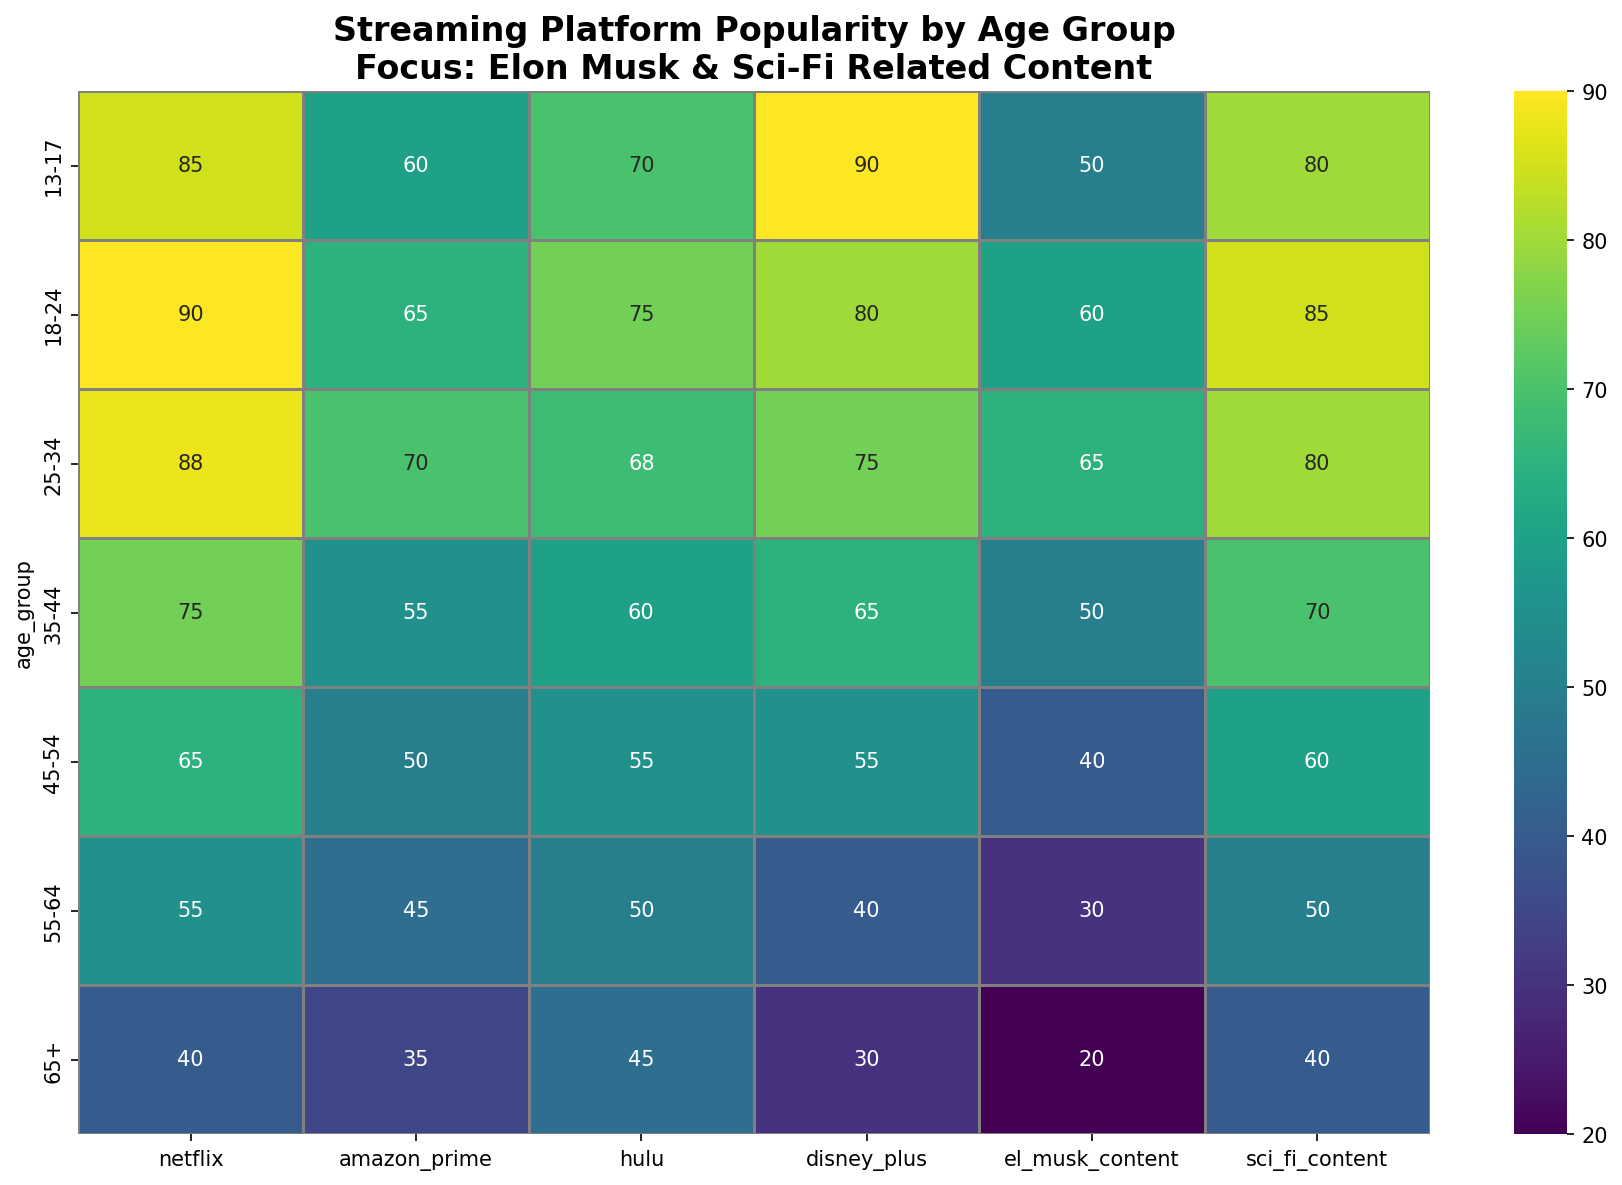What age group has the highest interest in content related to Elon Musk? By looking at the heatmap, we see that the el_musk_content column has the highest value in the 25-34 age group with 65.
Answer: 25-34 Which streaming platform is most popular among the 45-54 age group? The heatmap shows the highest value in the 45-54 age group is for Netflix at 65.
Answer: Netflix What is the difference in popularity of sci-fi content between the 13-17 and 55-64 age groups? The popularity of sci-fi content for ages 13-17 is 80, and for ages 55-64 it is 50. The difference between them is 80 - 50 = 30.
Answer: 30 How does the popularity of Hulu compare between the 18-24 and 35-44 age groups? In the heatmap, the value for Hulu in the 18-24 age group is 75, while that for the 35-44 age group is 60. Thus, Hulu is more popular among the 18-24 age group by 15.
Answer: Hulu is 15 points more popular among the 18-24 age group What is the average popularity of Disney+ across all age groups? To find the average, sum up the Disney+ values for all age groups: 90 + 80 + 75 + 65 + 55 + 40 + 30 = 435. There are 7 age groups, so the average is 435 / 7 ≈ 62.14.
Answer: 62.14 Which age group shows the least interest in content related to Elon Musk? According to the heatmap, the lowest value in the el_musk_content column is in the 65+ age group, with a value of 20.
Answer: 65+ What is the total popularity of Netflix and Amazon Prime in the 25-34 age group? For the 25-34 age group, the popularity of Netflix is 88 and Amazon Prime is 70. Totaling them gives 88 + 70 = 158.
Answer: 158 What is the ratio of interest in sci-fi content between the 18-24 and 35-44 age groups? For the 18-24 age group, sci-fi content interest is 85, and for 35-44, it is 70. The ratio is 85 / 70 ≈ 1.21.
Answer: 1.21 